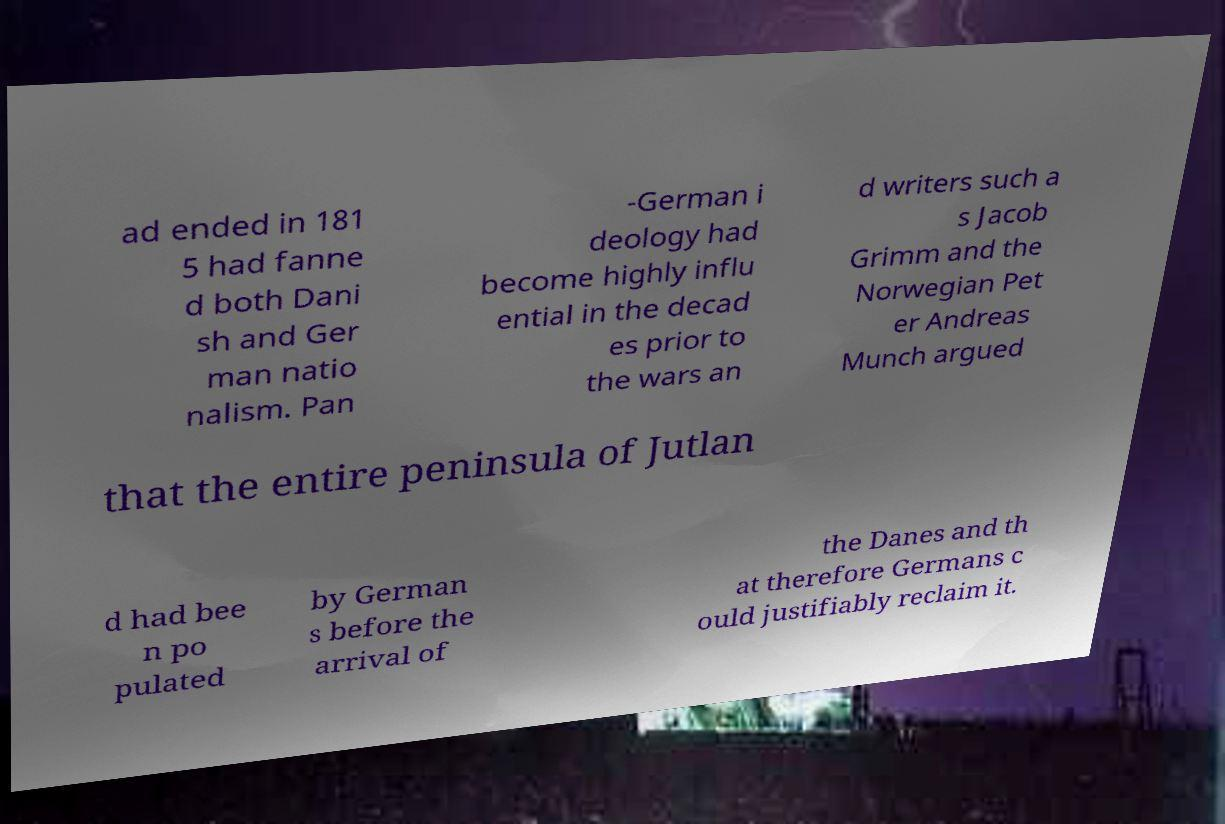Please identify and transcribe the text found in this image. ad ended in 181 5 had fanne d both Dani sh and Ger man natio nalism. Pan -German i deology had become highly influ ential in the decad es prior to the wars an d writers such a s Jacob Grimm and the Norwegian Pet er Andreas Munch argued that the entire peninsula of Jutlan d had bee n po pulated by German s before the arrival of the Danes and th at therefore Germans c ould justifiably reclaim it. 